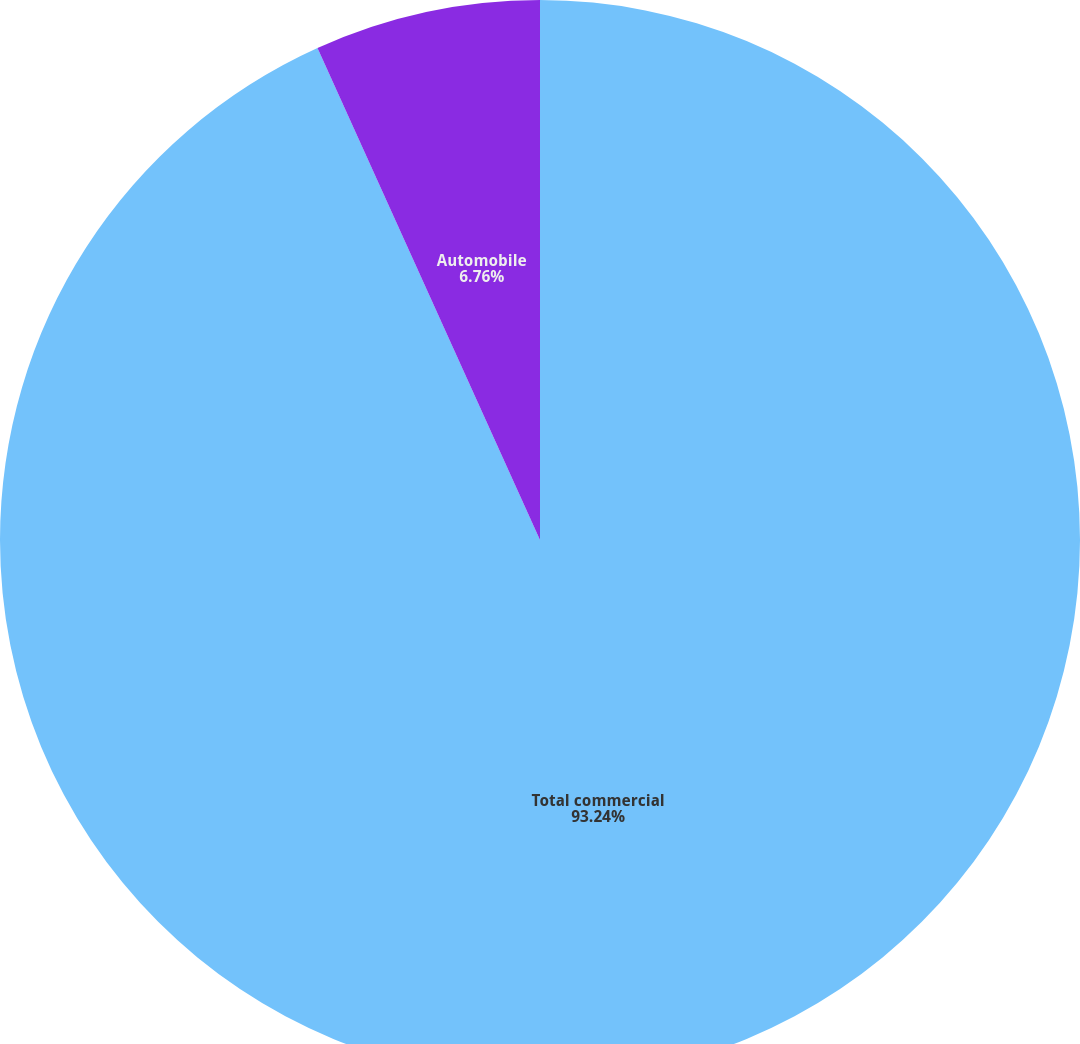<chart> <loc_0><loc_0><loc_500><loc_500><pie_chart><fcel>Total commercial<fcel>Automobile<nl><fcel>93.24%<fcel>6.76%<nl></chart> 